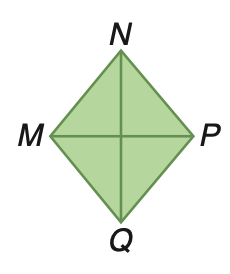Question: Rhombus M N P Q has an area of 375 square inches. If M P is 25 inches, find N Q.
Choices:
A. 15
B. 25
C. 30
D. 50
Answer with the letter. Answer: C 